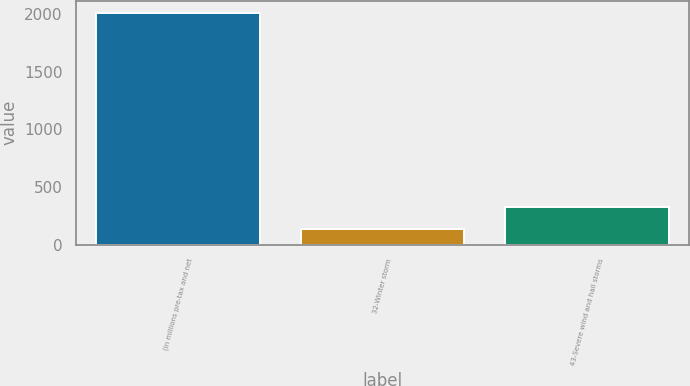Convert chart. <chart><loc_0><loc_0><loc_500><loc_500><bar_chart><fcel>(in millions pre-tax and net<fcel>32-Winter storm<fcel>43-Severe wind and hail storms<nl><fcel>2016<fcel>138<fcel>325.8<nl></chart> 